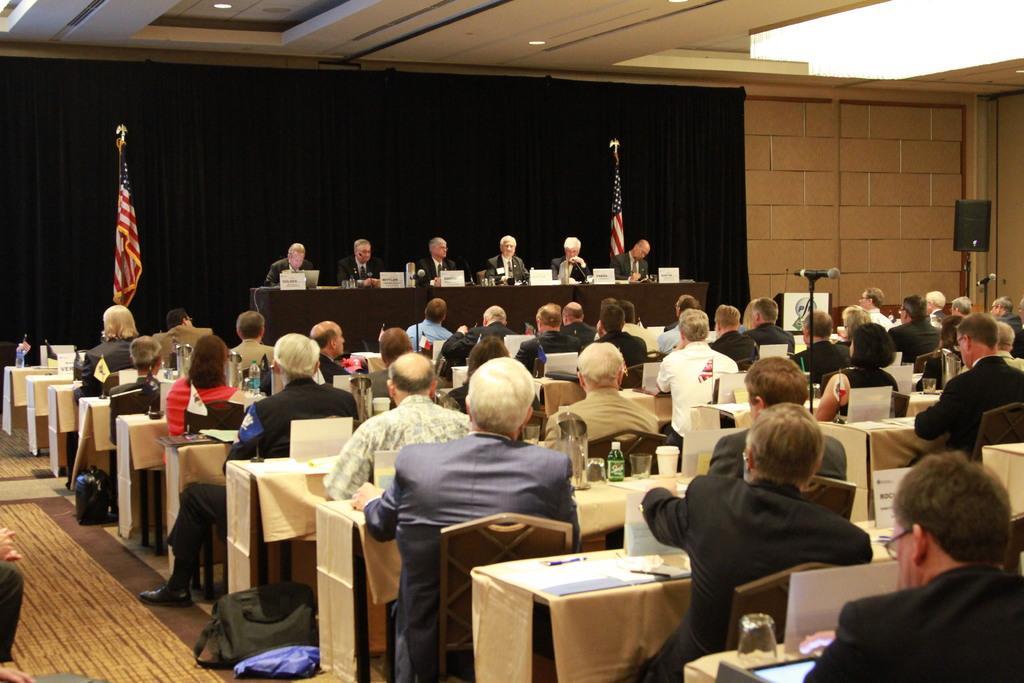How would you summarize this image in a sentence or two? This picture describes about group of people who are all seated on the chair, in front of them we can see cups, bottle on the table and also we can see bags, microphone, a sound box and flag. 